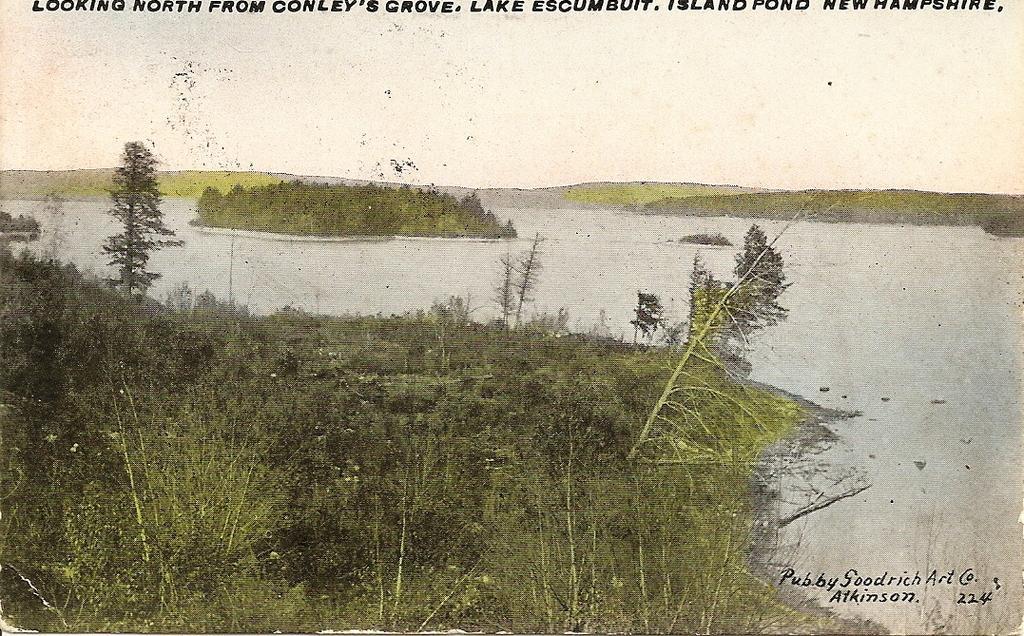Please provide a concise description of this image. This is an edited image in which in the front there are plants. In the center there is water. In the background there are plants and there is grass. 